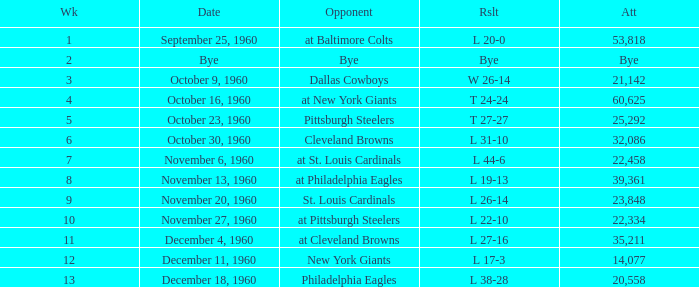Which Week had a Date of december 4, 1960? 11.0. 